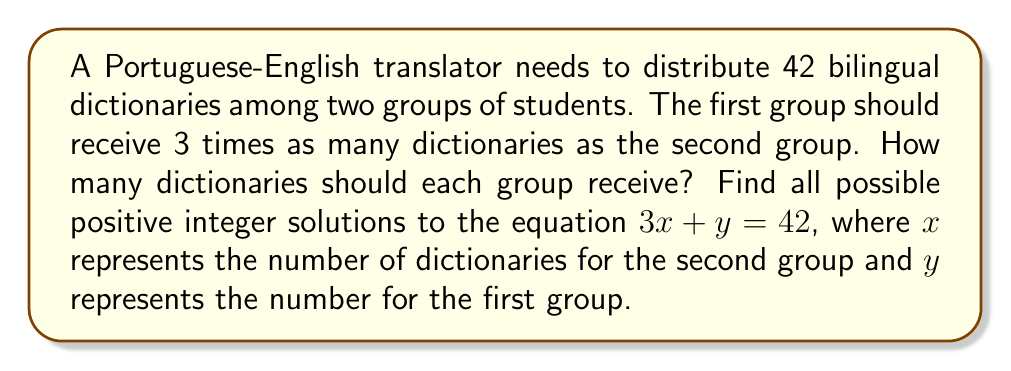Can you solve this math problem? To solve this linear Diophantine equation, we'll follow these steps:

1) We have the equation $3x + y = 42$, where $x$ and $y$ are positive integers.

2) First, check if a solution exists. The GCD of the coefficients (3 and 1) must divide the constant term (42):
   $\gcd(3,1) = 1$, and 1 divides 42, so a solution exists.

3) Rearrange the equation: $y = 42 - 3x$

4) Since $x$ and $y$ must be positive integers:
   $42 - 3x > 0$
   $42 > 3x$
   $14 > x$

5) Also, $x$ must be a positive integer, so $x \geq 1$

6) Therefore, the possible values for $x$ are 1, 2, 3, 4, 5, 6, 7, 8, 9, 10, 11, 12, 13

7) Calculate corresponding $y$ values:
   When $x = 1$, $y = 42 - 3(1) = 39$
   When $x = 2$, $y = 42 - 3(2) = 36$
   ...
   When $x = 13$, $y = 42 - 3(13) = 3$

8) The solutions satisfying the condition that the first group (y) should receive 3 times as many as the second group (x) are:
   $x = 10$, $y = 30$
   $x = 11$, $y = 33$

Therefore, there are two possible solutions that satisfy all conditions.
Answer: (10, 30) and (11, 33) 